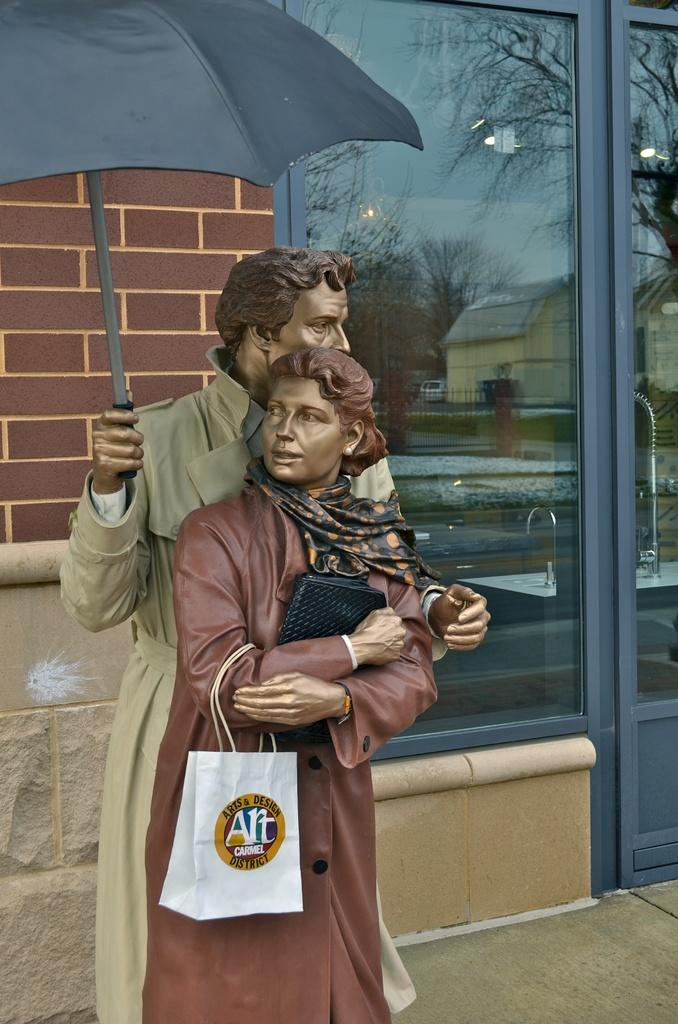What can be seen in the image that represents artistic creations? There are statues in the image. What type of reflections can be seen in the image? There are reflections of buildings and motor vehicles in the image. What type of natural elements can be seen in the image? There are trees visible in the image. What part of the natural environment is visible in the image? The sky is visible in the image. What architectural feature is present in the image? There is a window in the image. Where is the knife placed in the image? There is no knife present in the image. What type of furniture can be seen in the image? There is no furniture, such as a sofa, present in the image. 